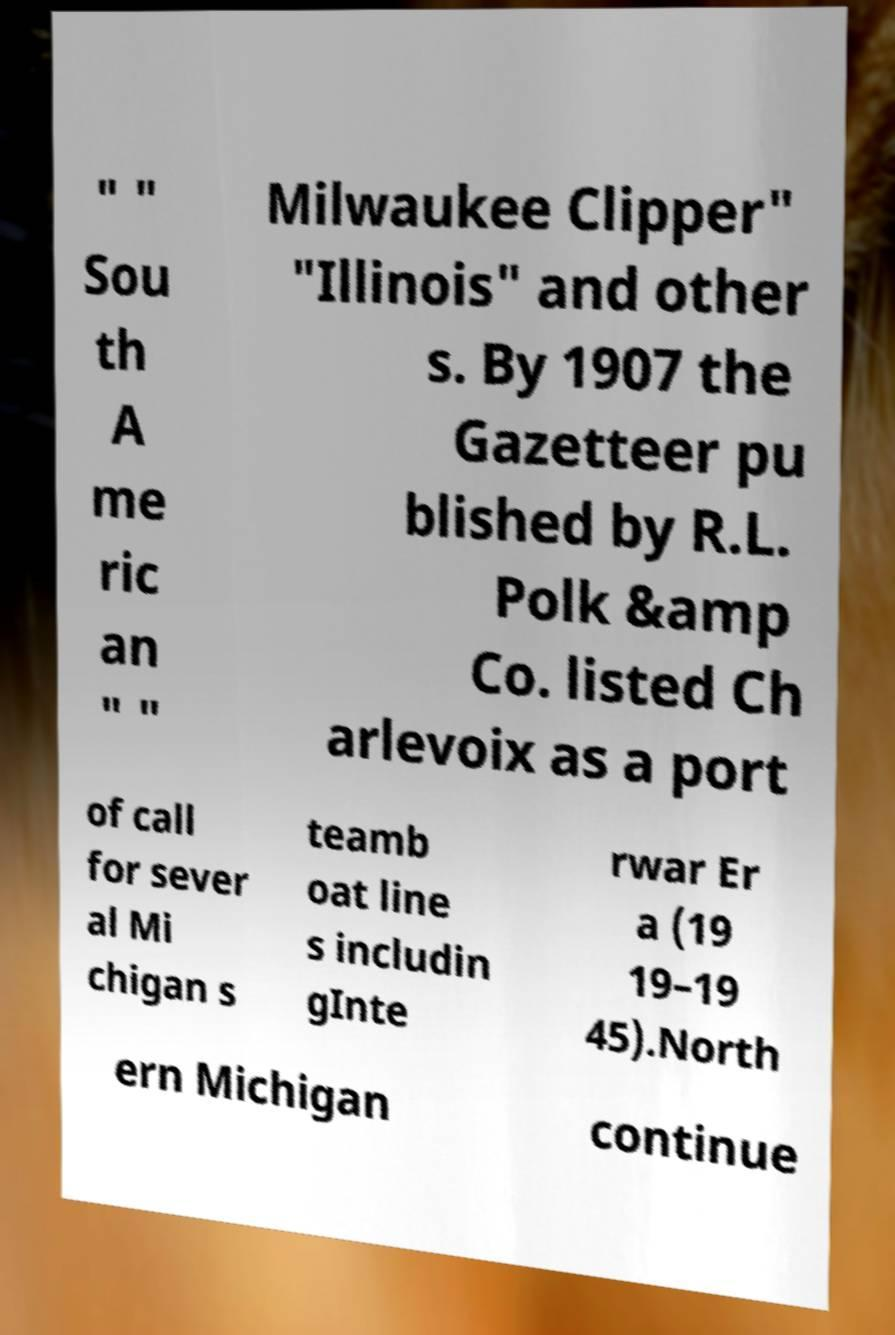Can you accurately transcribe the text from the provided image for me? " " Sou th A me ric an " " Milwaukee Clipper" "Illinois" and other s. By 1907 the Gazetteer pu blished by R.L. Polk &amp Co. listed Ch arlevoix as a port of call for sever al Mi chigan s teamb oat line s includin gInte rwar Er a (19 19–19 45).North ern Michigan continue 